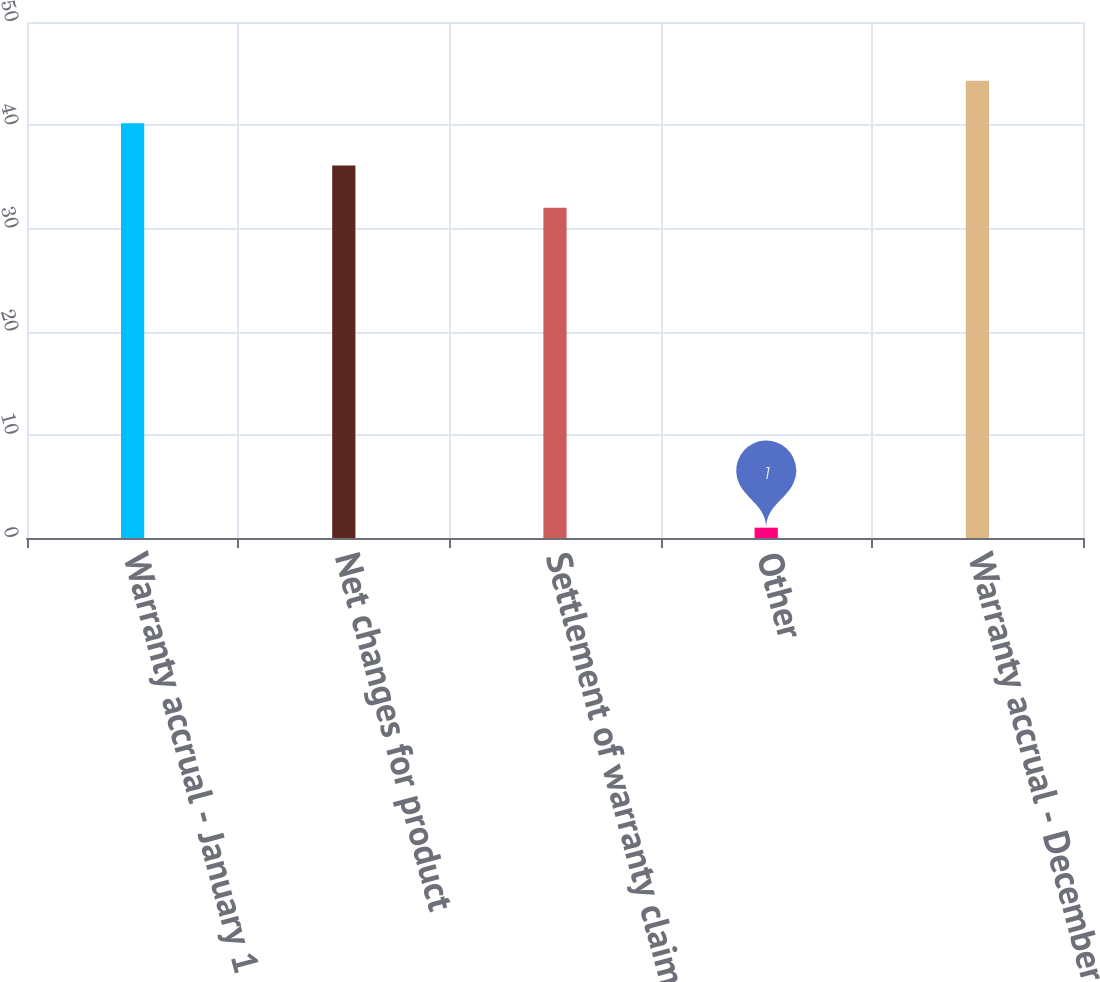Convert chart. <chart><loc_0><loc_0><loc_500><loc_500><bar_chart><fcel>Warranty accrual - January 1<fcel>Net changes for product<fcel>Settlement of warranty claims<fcel>Other<fcel>Warranty accrual - December 31<nl><fcel>40.2<fcel>36.1<fcel>32<fcel>1<fcel>44.3<nl></chart> 